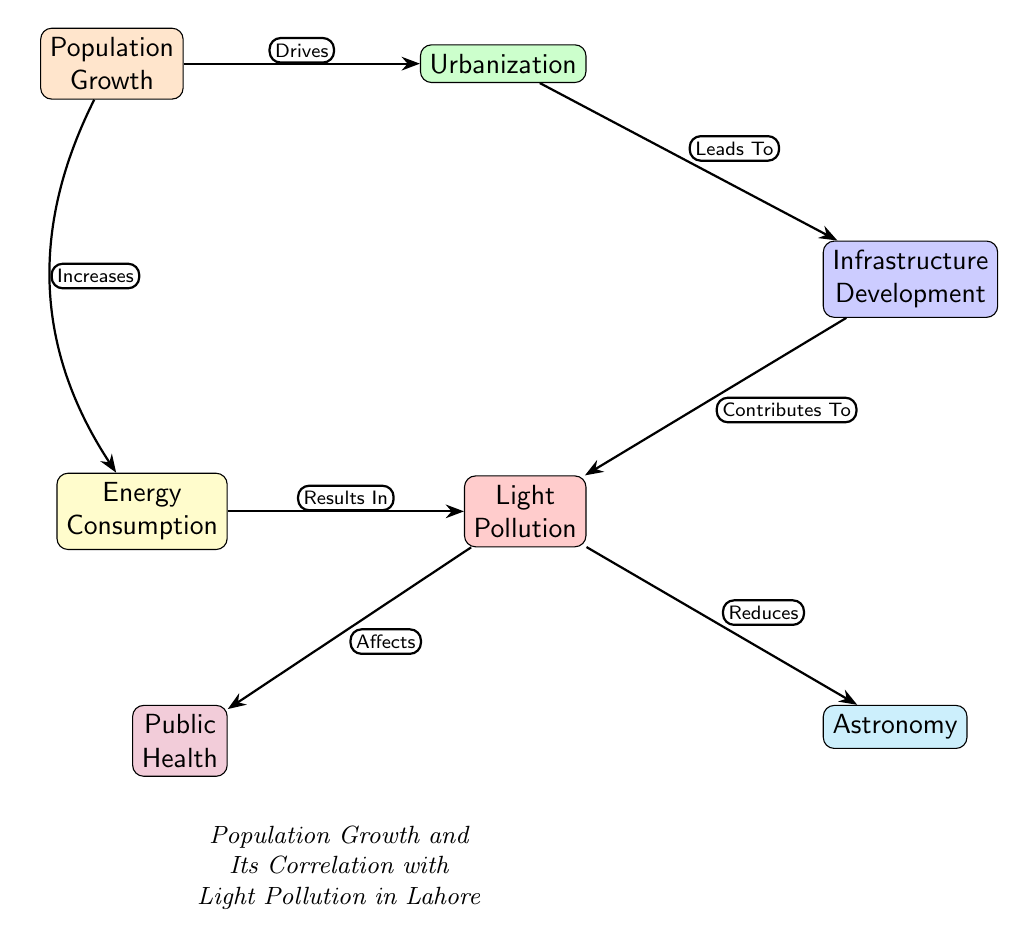What is the primary factor driving urbanization in Lahore? The diagram indicates that population growth is the primary driving factor for urbanization, as denoted by the edge labeled "Drives."
Answer: Population Growth Which two nodes are directly affected by light pollution according to the diagram? Light pollution directly affects public health and astronomy based on the connections shown in the diagram: "Affects" leads to health, and "Reduces" leads to astronomy.
Answer: Public Health, Astronomy How many nodes are present in this diagram? By counting the filled nodes listed in the diagram, we identify seven distinct nodes: Population Growth, Urbanization, Infrastructure Development, Light Pollution, Energy Consumption, Public Health, and Astronomy.
Answer: 7 What is the relationship between infrastructure development and light pollution? The diagram shows that infrastructure development contributes to light pollution, as noted by the edge labeled "Contributes To."
Answer: Contributes To What do energy consumption and population growth have in common according to the diagram? Both energy consumption and population growth share a direct correlation, with population growth increasing energy consumption, indicated by the edge labeled "Increases."
Answer: Increases Which node represents the environmental concern in the diagram? The node representing the environmental concern is light pollution, which has connections to both public health and astronomy, highlighting its impacts.
Answer: Light Pollution What effect does urbanization have on infrastructure development? The diagram indicates that urbanization leads to infrastructure development through the connection labeled "Leads To."
Answer: Leads To How does energy consumption relate to light pollution in this diagram? The diagram indicates that energy consumption results in light pollution, as denoted by the edge labeled "Results In."
Answer: Results In What aspect of society is tied to light pollution in the diagram? Light pollution is tied to public health in the diagram, which is illustrated by the connection indicating that light pollution affects health.
Answer: Public Health 